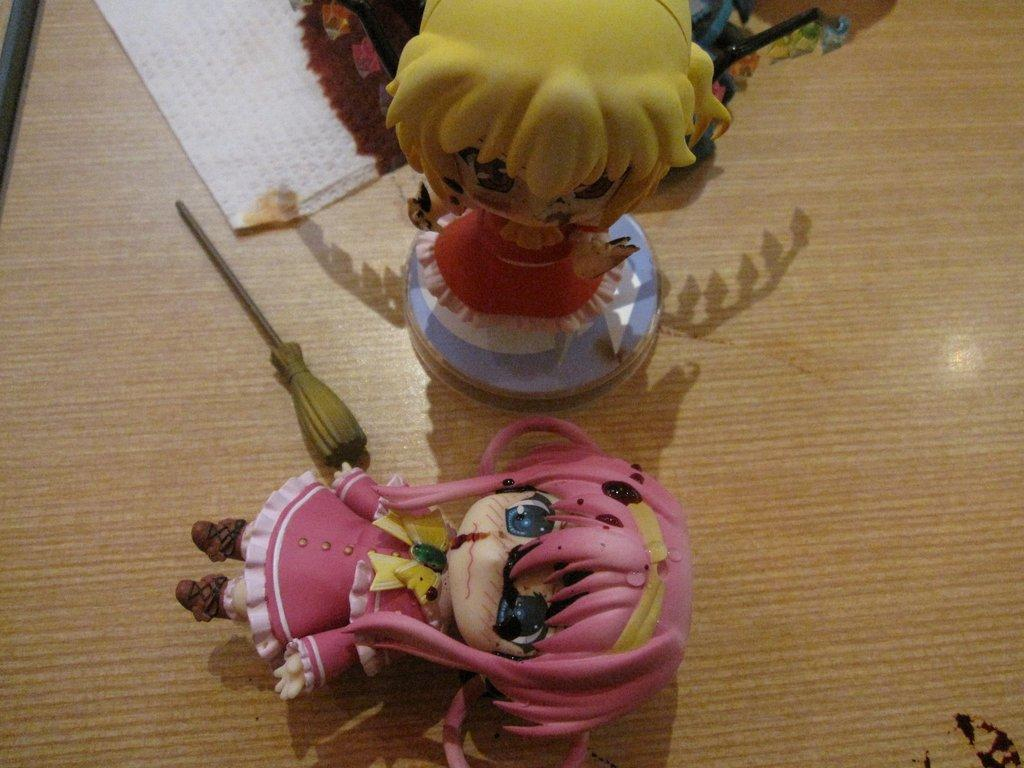What type of toys are in the image? There are doll toys in the image. What material is the surface on which the doll toys are placed? The doll toys are on a wooden surface. What word is written on the doll toys in the image? There is no word written on the doll toys in the image. Are there any fairies present in the image? There are no fairies present in the image; it only features doll toys. 